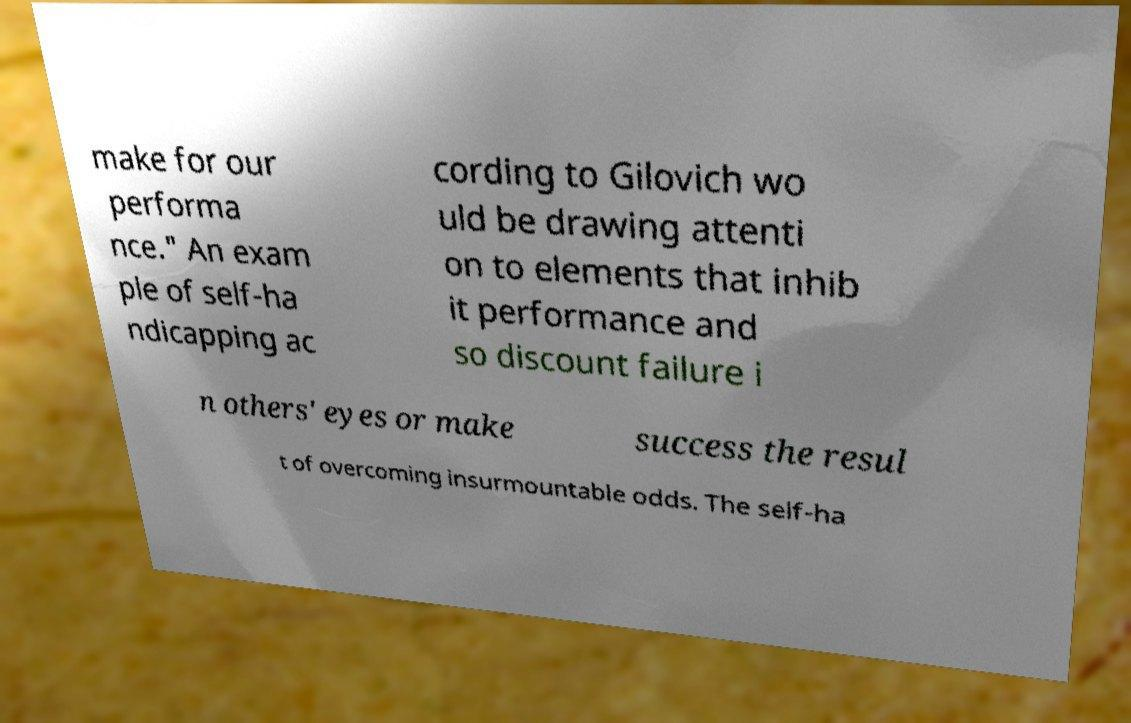What messages or text are displayed in this image? I need them in a readable, typed format. make for our performa nce." An exam ple of self-ha ndicapping ac cording to Gilovich wo uld be drawing attenti on to elements that inhib it performance and so discount failure i n others' eyes or make success the resul t of overcoming insurmountable odds. The self-ha 